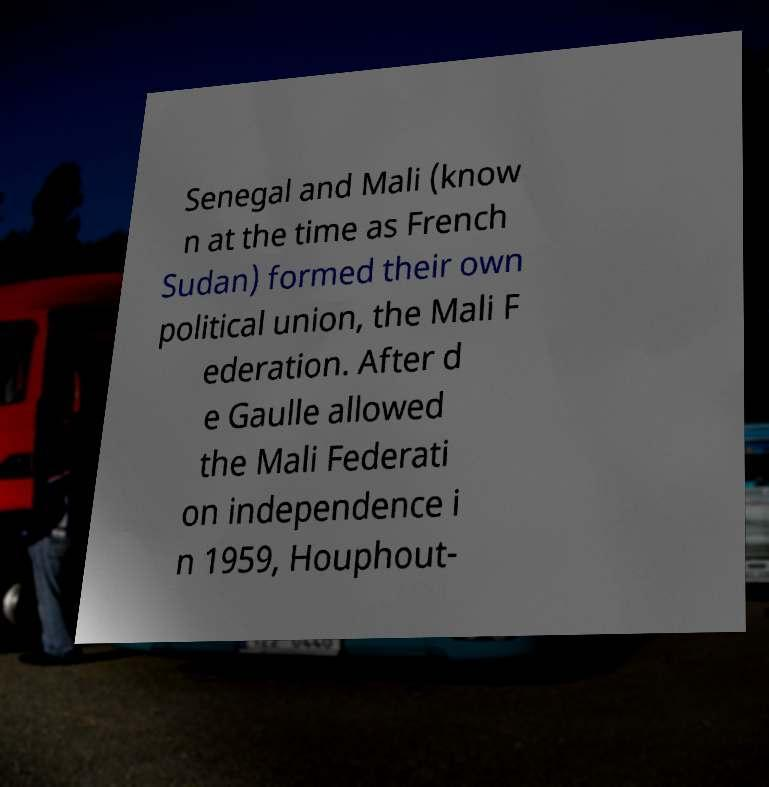I need the written content from this picture converted into text. Can you do that? Senegal and Mali (know n at the time as French Sudan) formed their own political union, the Mali F ederation. After d e Gaulle allowed the Mali Federati on independence i n 1959, Houphout- 